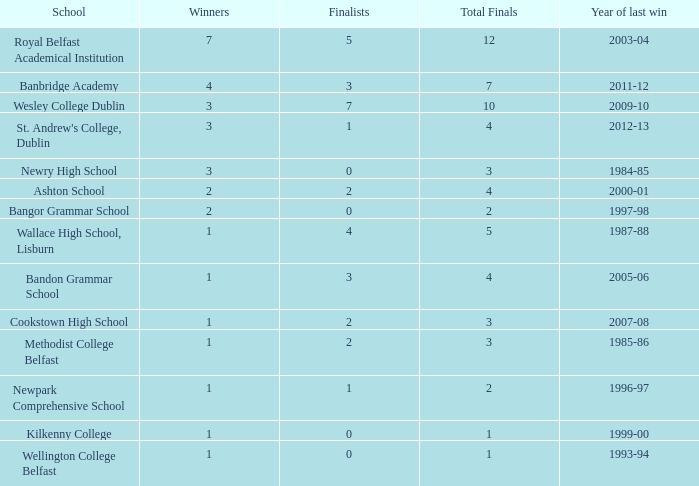How many total finals where there when the last win was in 2012-13? 4.0. Would you mind parsing the complete table? {'header': ['School', 'Winners', 'Finalists', 'Total Finals', 'Year of last win'], 'rows': [['Royal Belfast Academical Institution', '7', '5', '12', '2003-04'], ['Banbridge Academy', '4', '3', '7', '2011-12'], ['Wesley College Dublin', '3', '7', '10', '2009-10'], ["St. Andrew's College, Dublin", '3', '1', '4', '2012-13'], ['Newry High School', '3', '0', '3', '1984-85'], ['Ashton School', '2', '2', '4', '2000-01'], ['Bangor Grammar School', '2', '0', '2', '1997-98'], ['Wallace High School, Lisburn', '1', '4', '5', '1987-88'], ['Bandon Grammar School', '1', '3', '4', '2005-06'], ['Cookstown High School', '1', '2', '3', '2007-08'], ['Methodist College Belfast', '1', '2', '3', '1985-86'], ['Newpark Comprehensive School', '1', '1', '2', '1996-97'], ['Kilkenny College', '1', '0', '1', '1999-00'], ['Wellington College Belfast', '1', '0', '1', '1993-94']]} 